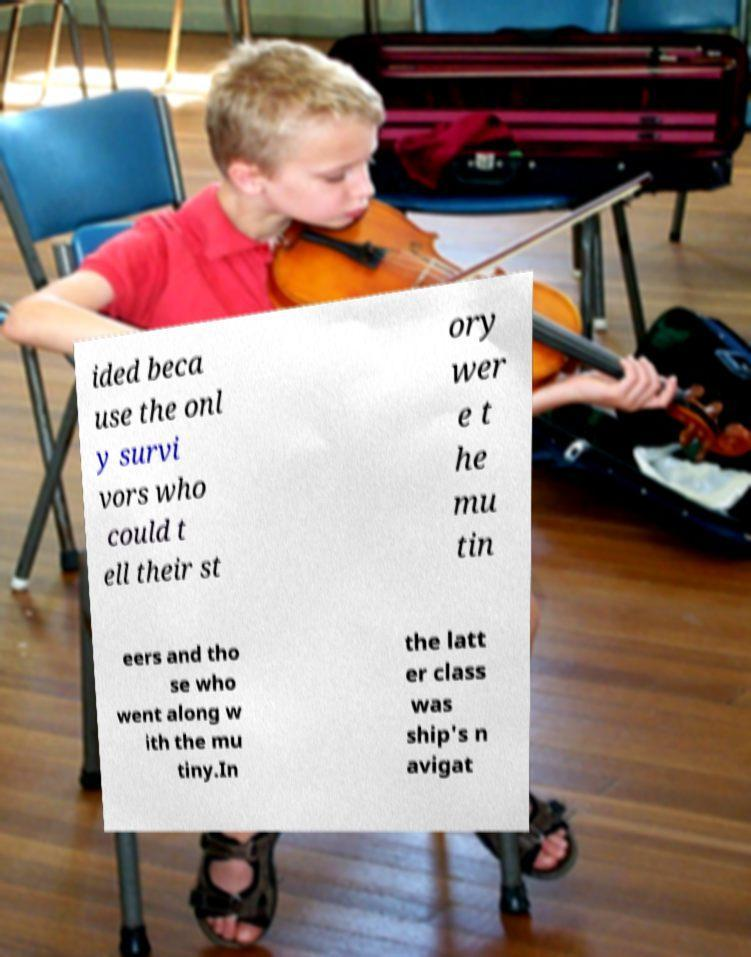Can you read and provide the text displayed in the image?This photo seems to have some interesting text. Can you extract and type it out for me? ided beca use the onl y survi vors who could t ell their st ory wer e t he mu tin eers and tho se who went along w ith the mu tiny.In the latt er class was ship's n avigat 